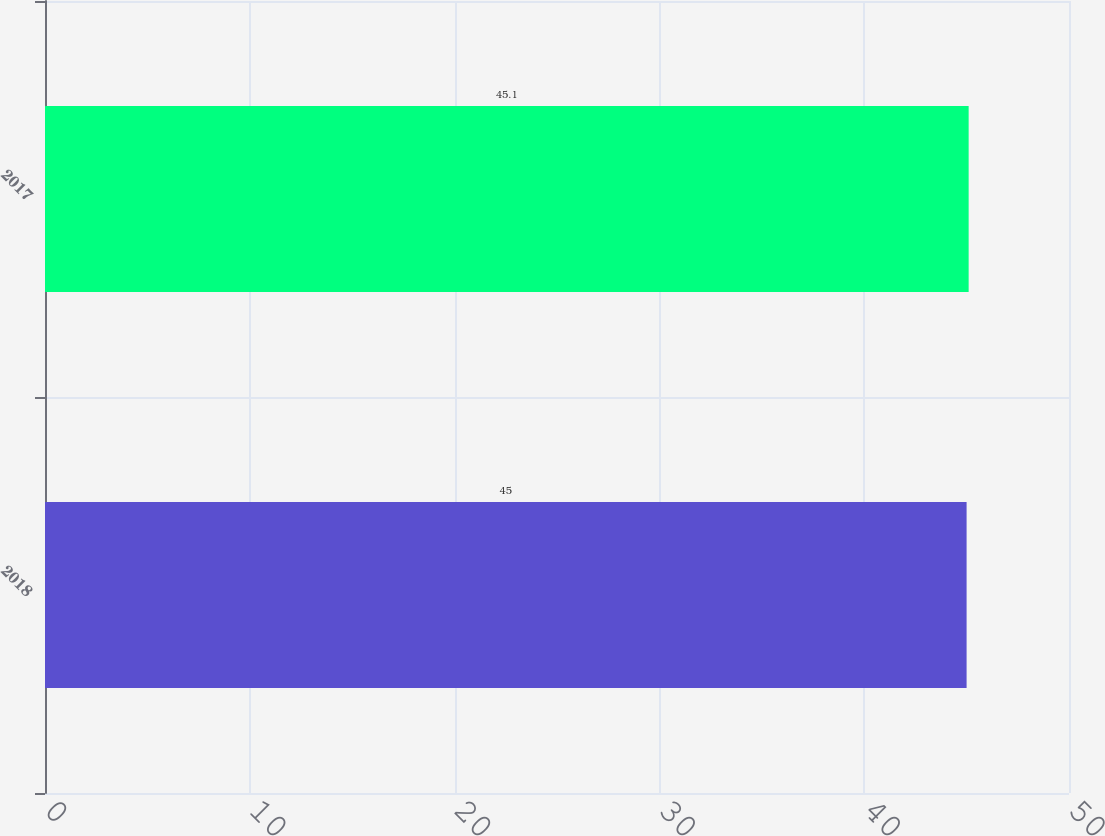Convert chart to OTSL. <chart><loc_0><loc_0><loc_500><loc_500><bar_chart><fcel>2018<fcel>2017<nl><fcel>45<fcel>45.1<nl></chart> 